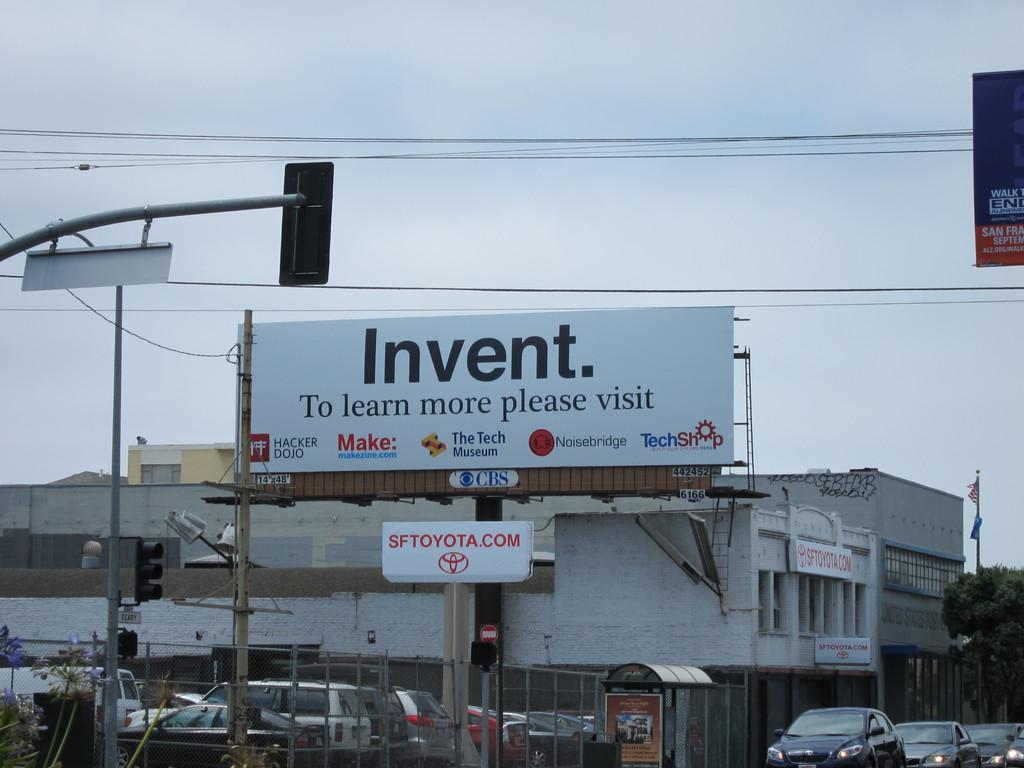<image>
Render a clear and concise summary of the photo. A Toyota website url is posted below a billboard. 